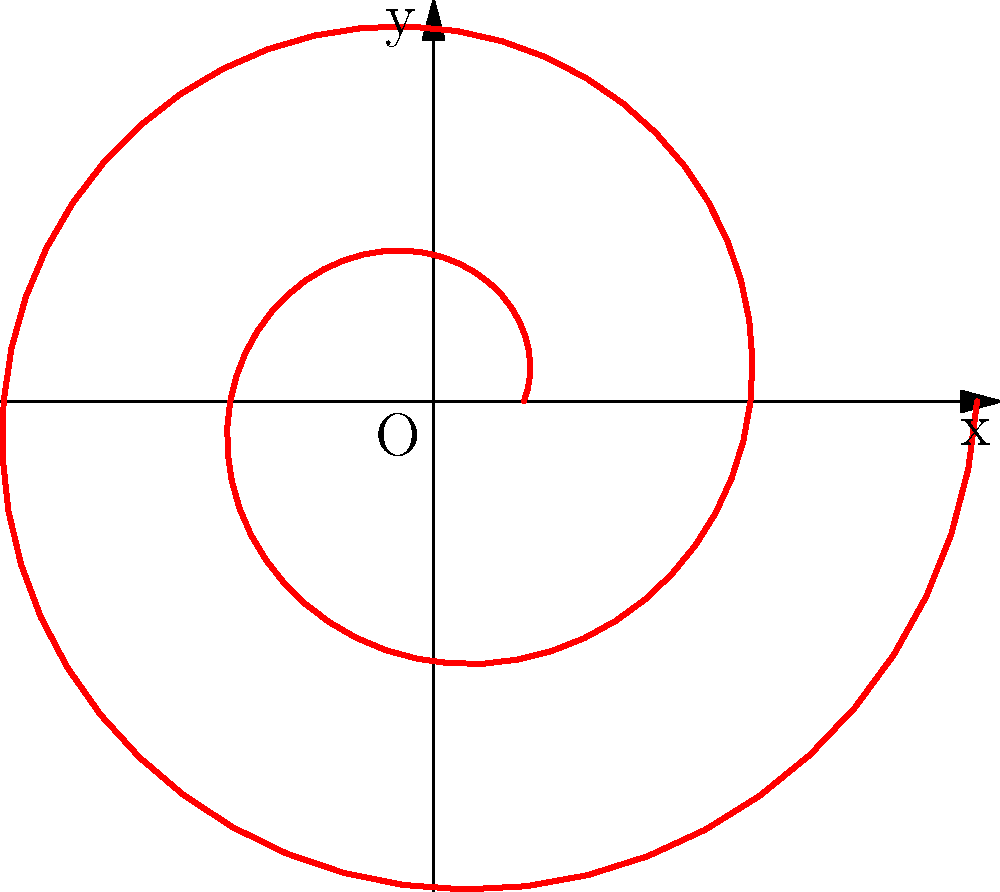A conch shell's spiral pattern can be represented in polar form by the equation $r = 0.5 + 0.2\theta$. If a Caribbean-inspired dish is plated following this spiral, starting from $\theta = 0$ and ending at $\theta = 4\pi$, what is the total angular distance traveled by the spiral? To find the total angular distance traveled by the spiral, we need to follow these steps:

1) The spiral starts at $\theta = 0$ and ends at $\theta = 4\pi$.

2) In polar coordinates, the angular distance is simply the difference between the ending and starting angles.

3) Calculate the difference:
   $\text{Angular distance} = \text{End angle} - \text{Start angle}$
   $\text{Angular distance} = 4\pi - 0 = 4\pi$

4) The result $4\pi$ is in radians. We can convert it to degrees if needed:
   $4\pi \text{ radians} = 4\pi \cdot \frac{180°}{\pi} = 720°$

5) Therefore, the total angular distance traveled by the spiral is $4\pi$ radians or 720°.

This spiral pattern could inspire a unique plating technique, where Caribbean-inspired ingredients are arranged in a gradually expanding curve, mirroring the natural beauty of a conch shell often found in Caribbean waters.
Answer: $4\pi$ radians 